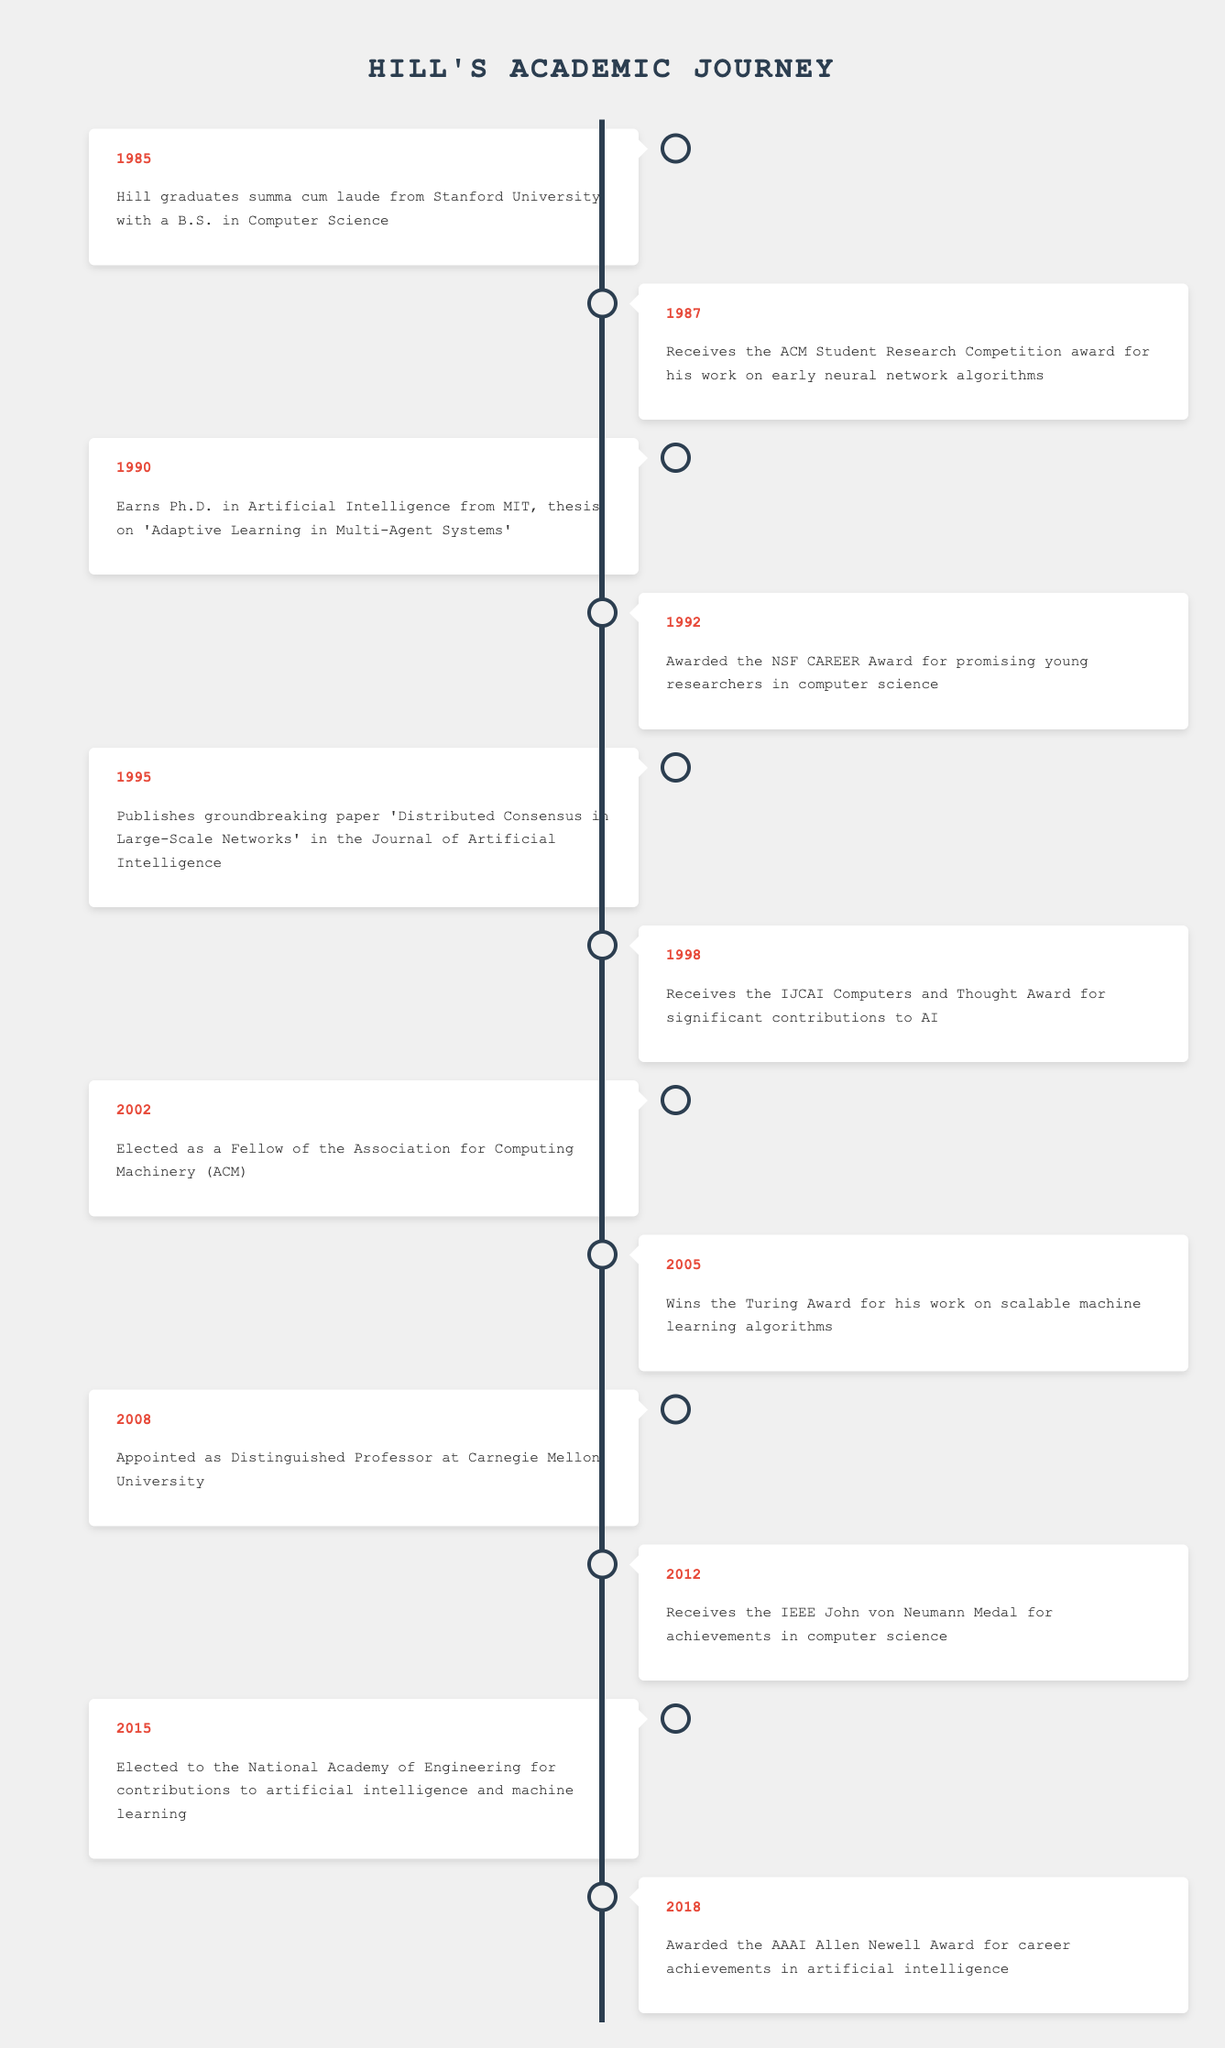What year did Hill graduate from Stanford University? Hill graduated summa cum laude from Stanford University in 1985, according to the first entry in the timeline.
Answer: 1985 Which award did Hill receive in 1998? In 1998, Hill received the IJCAI Computers and Thought Award, which is specified in that year's achievement in the timeline.
Answer: IJCAI Computers and Thought Award How many years passed between Hill receiving the Turing Award and the IEEE John von Neumann Medal? Hill received the Turing Award in 2005 and the IEEE John von Neumann Medal in 2012. The difference between 2012 and 2005 is 7 years.
Answer: 7 years Did Hill win an award during his time as a student? Yes, Hill received the ACM Student Research Competition award in 1987 while he was a student at Stanford.
Answer: Yes What are the years when Hill was awarded significant recognitions in the field of artificial intelligence? Hill was awarded the IJCAI Computers and Thought Award in 1998, the Turing Award in 2005, and the AAAI Allen Newell Award in 2018, making these the significant recognition years in artificial intelligence.
Answer: 1998, 2005, 2018 How many total awards did Hill receive between 1990 and 2015? From 1990 to 2015, Hill received the NSF CAREER Award (1992), IJCAI Computers and Thought Award (1998), Turing Award (2005), and was elected to the National Academy of Engineering (2015). That totals 4 awards during this time frame.
Answer: 4 In which year did Hill become a Fellow of the ACM? Hill was elected as a Fellow of the Association for Computing Machinery (ACM) in 2002, as indicated in the timeline.
Answer: 2002 Is it true that Hill published a groundbreaking paper in 1995? Yes, Hill published the paper 'Distributed Consensus in Large-Scale Networks' in 1995, which is confirmed by the timeline data.
Answer: Yes 